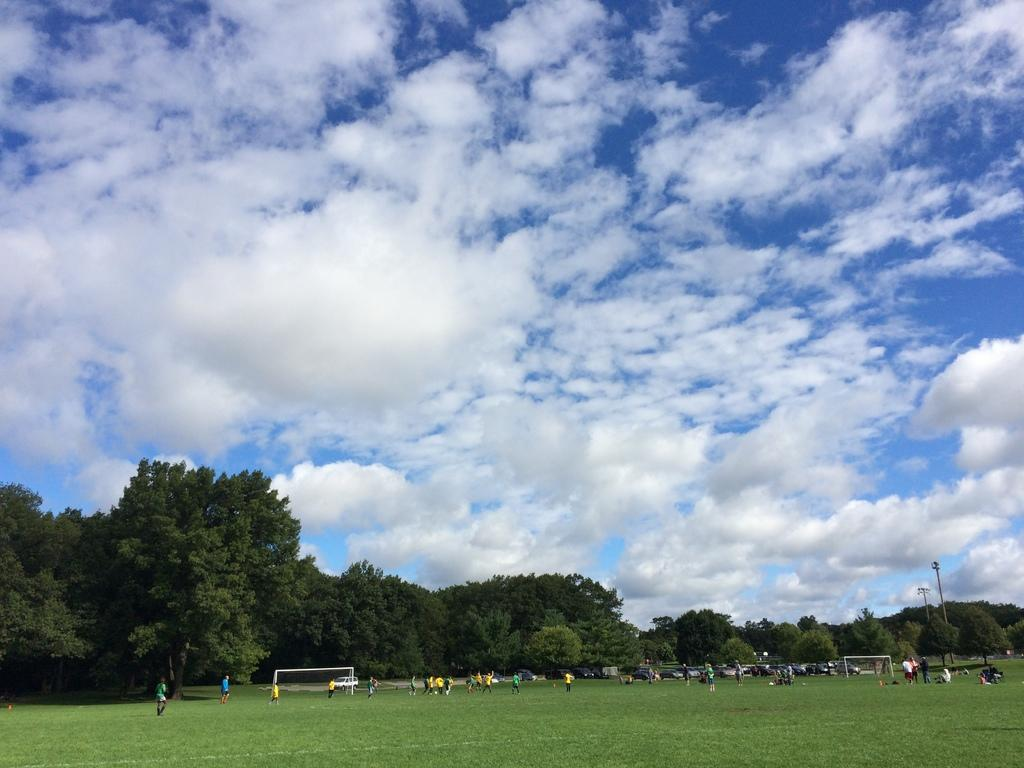What can be seen in the image involving groups of people? There are groups of people in the image. Where are the people located? The people are on the grass. What else is present in the image besides the groups of people? There are vehicles, football goal posts, poles, trees, and the sky visible in the background. What is the amount of patches on the football goal posts in the image? There are no patches mentioned or visible on the football goal posts in the image. 